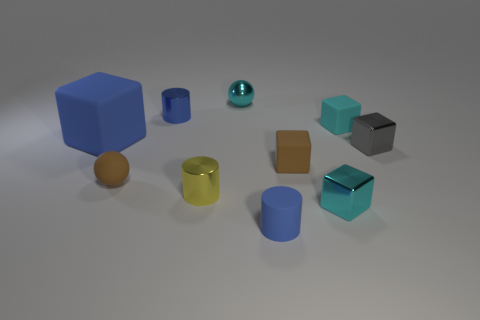Subtract all brown cubes. How many cubes are left? 4 Subtract all purple cubes. Subtract all purple spheres. How many cubes are left? 5 Subtract all balls. How many objects are left? 8 Add 1 small gray metal objects. How many small gray metal objects are left? 2 Add 7 cyan metallic things. How many cyan metallic things exist? 9 Subtract 0 blue spheres. How many objects are left? 10 Subtract all small blue metallic cylinders. Subtract all blue rubber cubes. How many objects are left? 8 